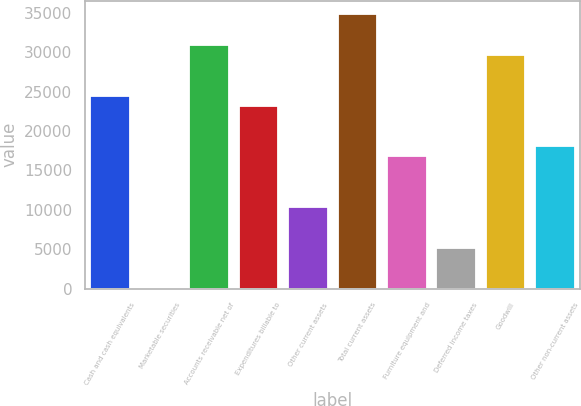Convert chart. <chart><loc_0><loc_0><loc_500><loc_500><bar_chart><fcel>Cash and cash equivalents<fcel>Marketable securities<fcel>Accounts receivable net of<fcel>Expenditures billable to<fcel>Other current assets<fcel>Total current assets<fcel>Furniture equipment and<fcel>Deferred income taxes<fcel>Goodwill<fcel>Other non-current assets<nl><fcel>24514.9<fcel>12.9<fcel>30962.8<fcel>23225.3<fcel>10329.5<fcel>34831.6<fcel>16777.4<fcel>5171.22<fcel>29673.2<fcel>18067<nl></chart> 